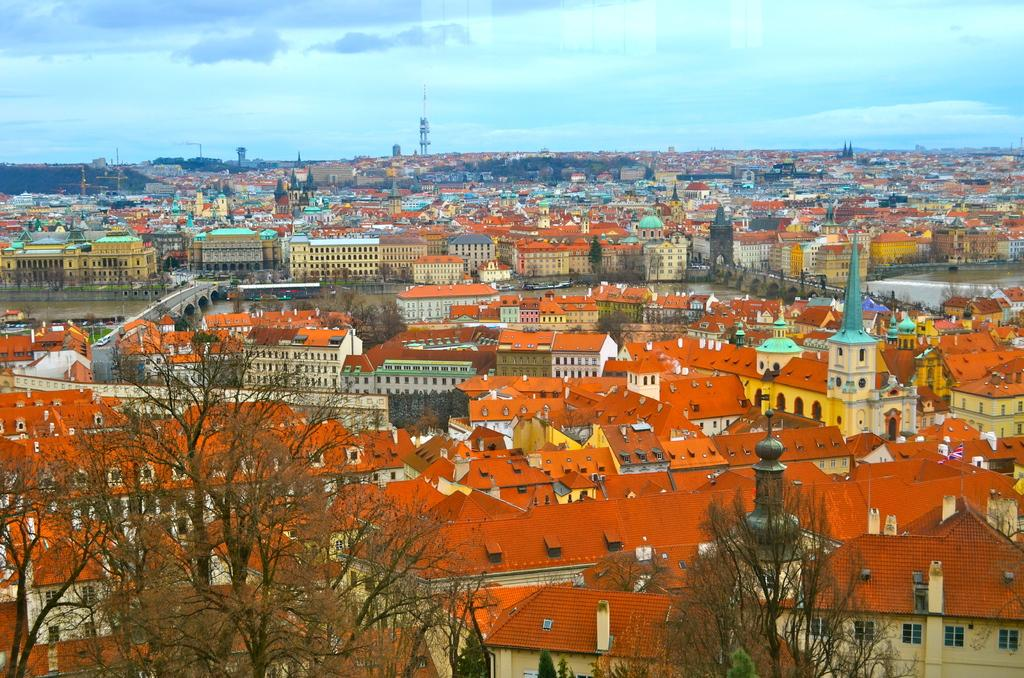What type of natural elements can be seen in the image? There are trees in the image. What type of man-made structures are present in the image? There are buildings in the image. What body of water is visible in the image? There is water visible in the image. How do people or vehicles cross the water in the image? There are bridges over the water in the image. Is there a veil covering the trees in the image? No, there is no veil present in the image. What type of shade is provided by the buildings in the image? The buildings in the image do not provide shade, as the focus is on the trees, water, and bridges. 